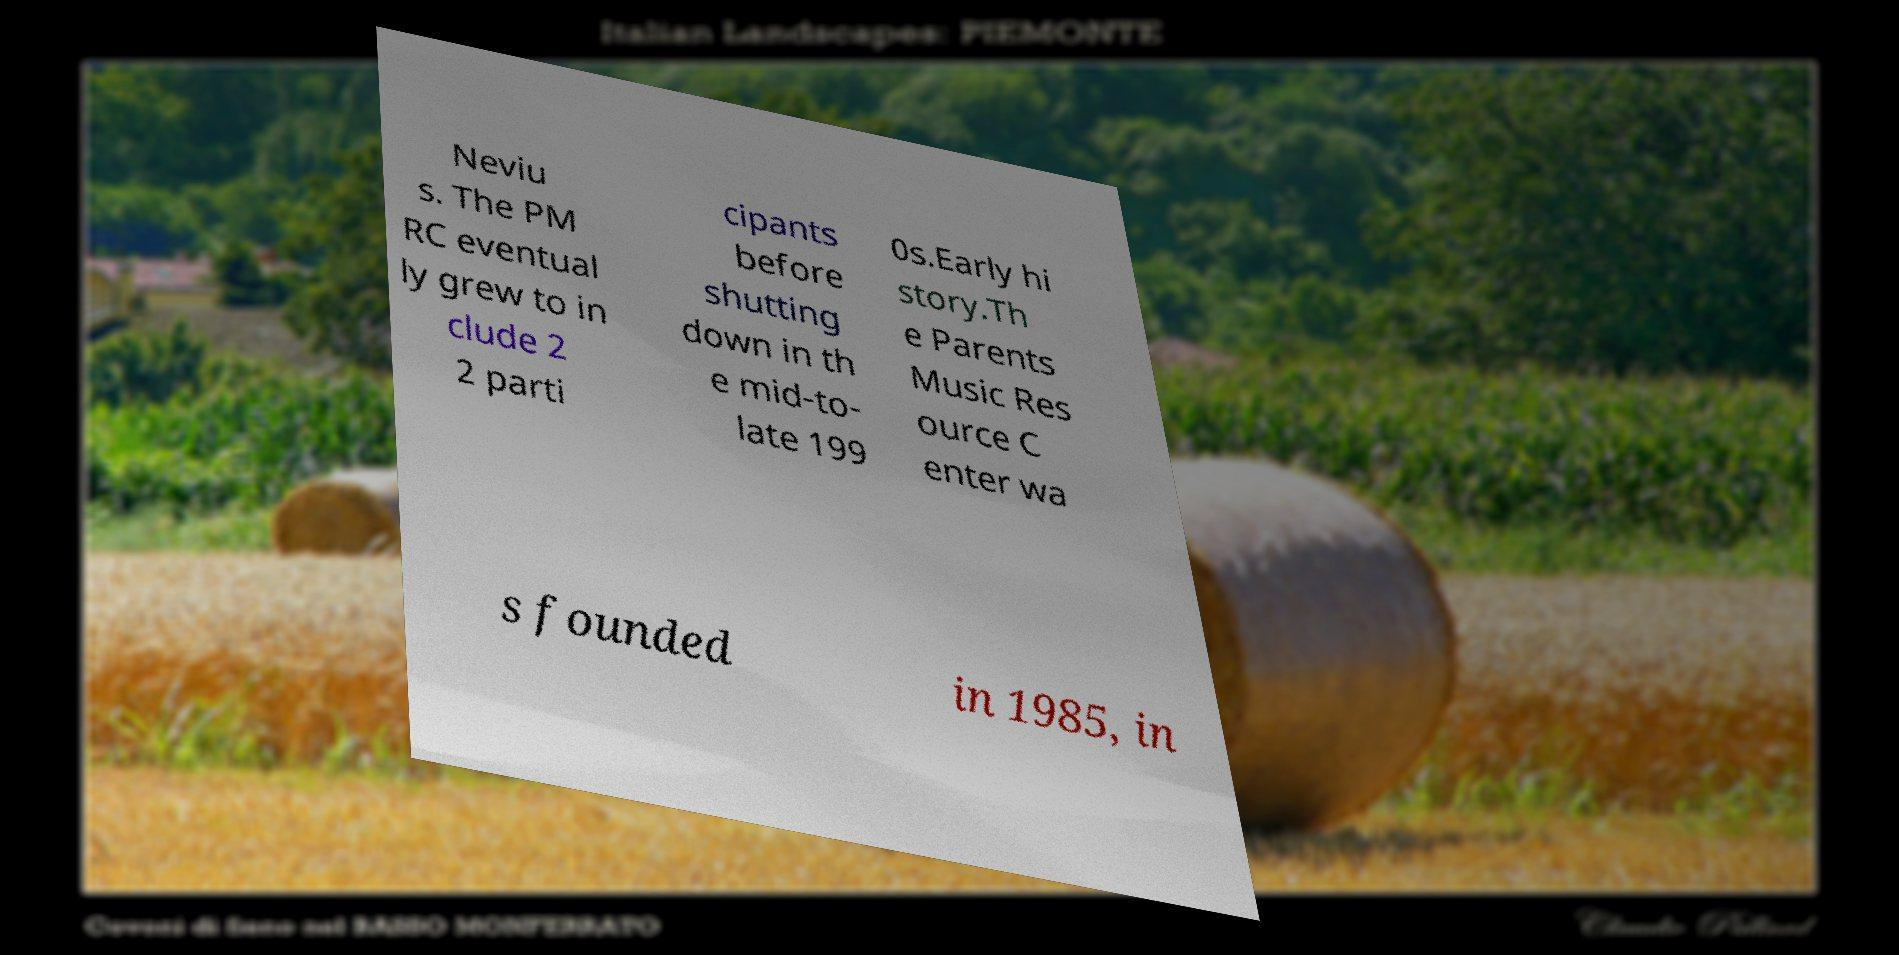Can you accurately transcribe the text from the provided image for me? Neviu s. The PM RC eventual ly grew to in clude 2 2 parti cipants before shutting down in th e mid-to- late 199 0s.Early hi story.Th e Parents Music Res ource C enter wa s founded in 1985, in 